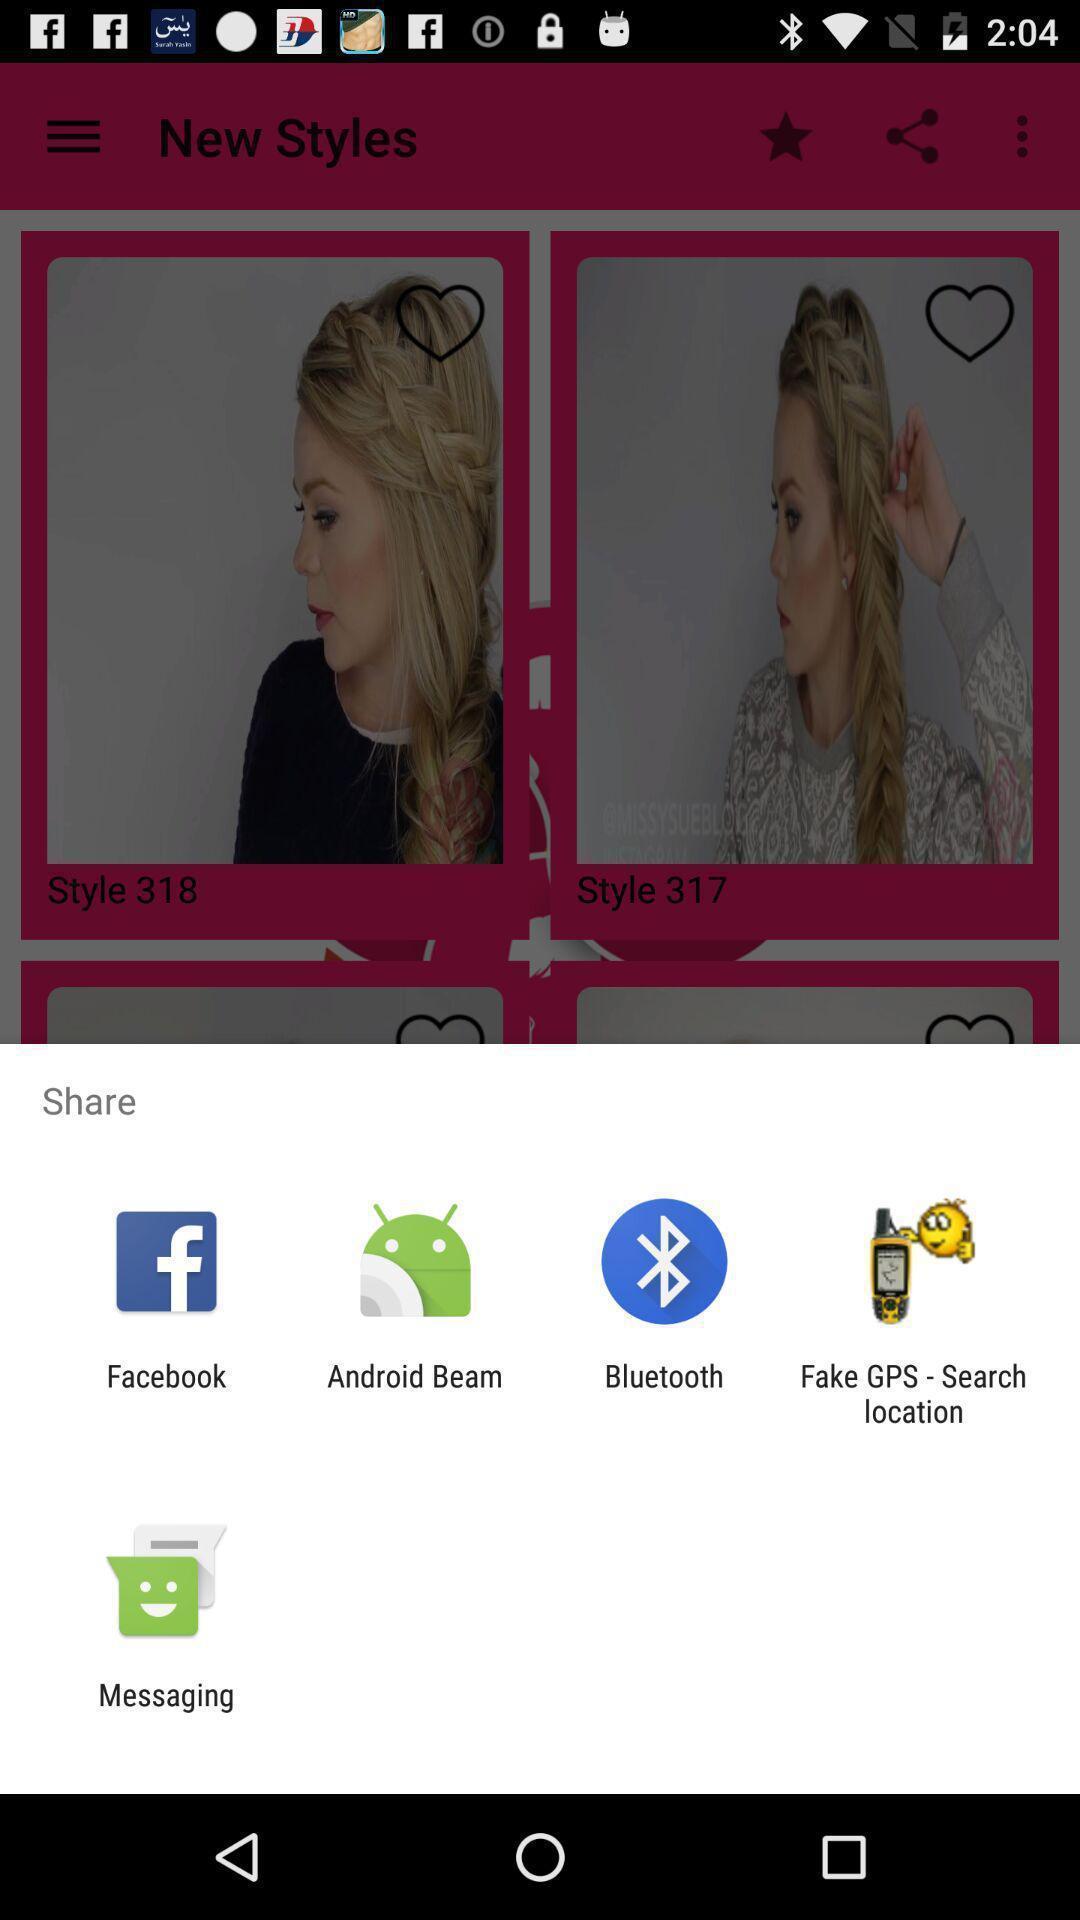Describe this image in words. Popup of applications to share the information. 